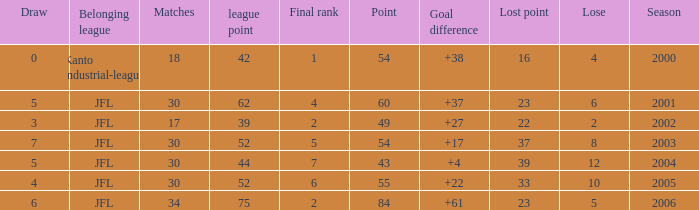Tell me the highest point with lost point being 33 and league point less than 52 None. Give me the full table as a dictionary. {'header': ['Draw', 'Belonging league', 'Matches', 'league point', 'Final rank', 'Point', 'Goal difference', 'Lost point', 'Lose', 'Season'], 'rows': [['0', 'Kanto industrial-league', '18', '42', '1', '54', '+38', '16', '4', '2000'], ['5', 'JFL', '30', '62', '4', '60', '+37', '23', '6', '2001'], ['3', 'JFL', '17', '39', '2', '49', '+27', '22', '2', '2002'], ['7', 'JFL', '30', '52', '5', '54', '+17', '37', '8', '2003'], ['5', 'JFL', '30', '44', '7', '43', '+4', '39', '12', '2004'], ['4', 'JFL', '30', '52', '6', '55', '+22', '33', '10', '2005'], ['6', 'JFL', '34', '75', '2', '84', '+61', '23', '5', '2006']]} 